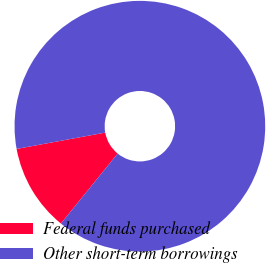<chart> <loc_0><loc_0><loc_500><loc_500><pie_chart><fcel>Federal funds purchased<fcel>Other short-term borrowings<nl><fcel>11.25%<fcel>88.75%<nl></chart> 